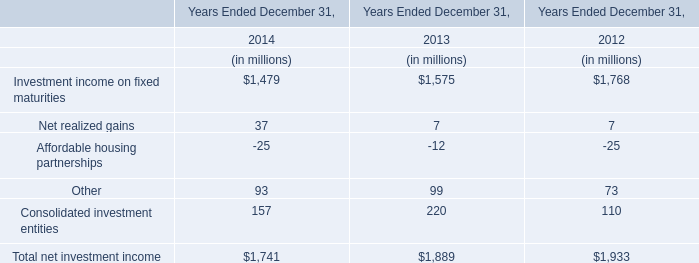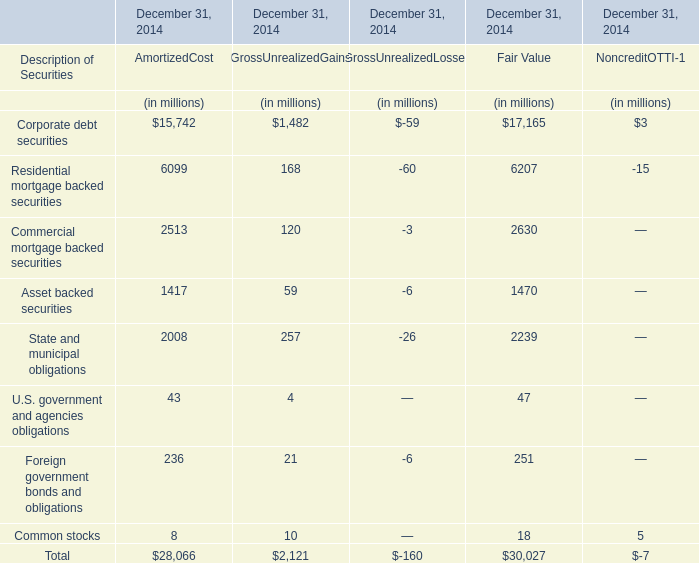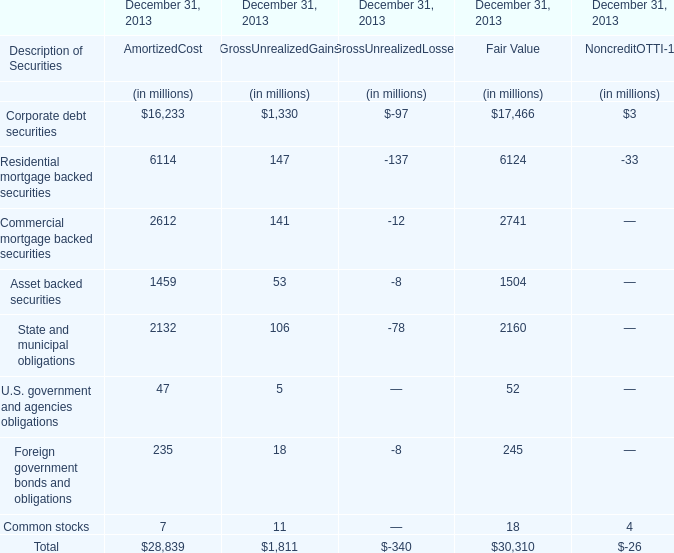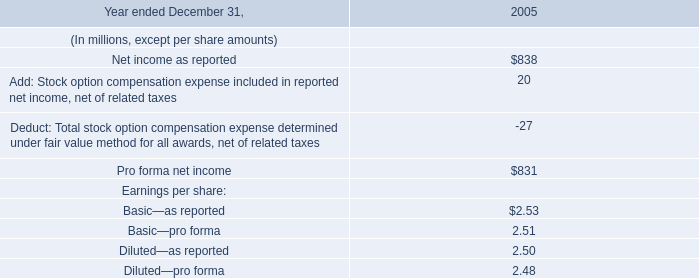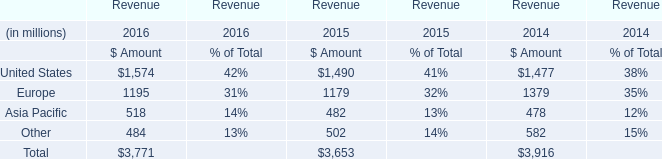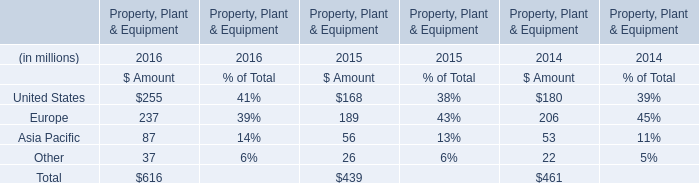What's the sum of the Residential mortgage backed securities in the years where Other is greater than 95? (in million) 
Computations: (((6114 + 147) - 137) - 33)
Answer: 6091.0. 